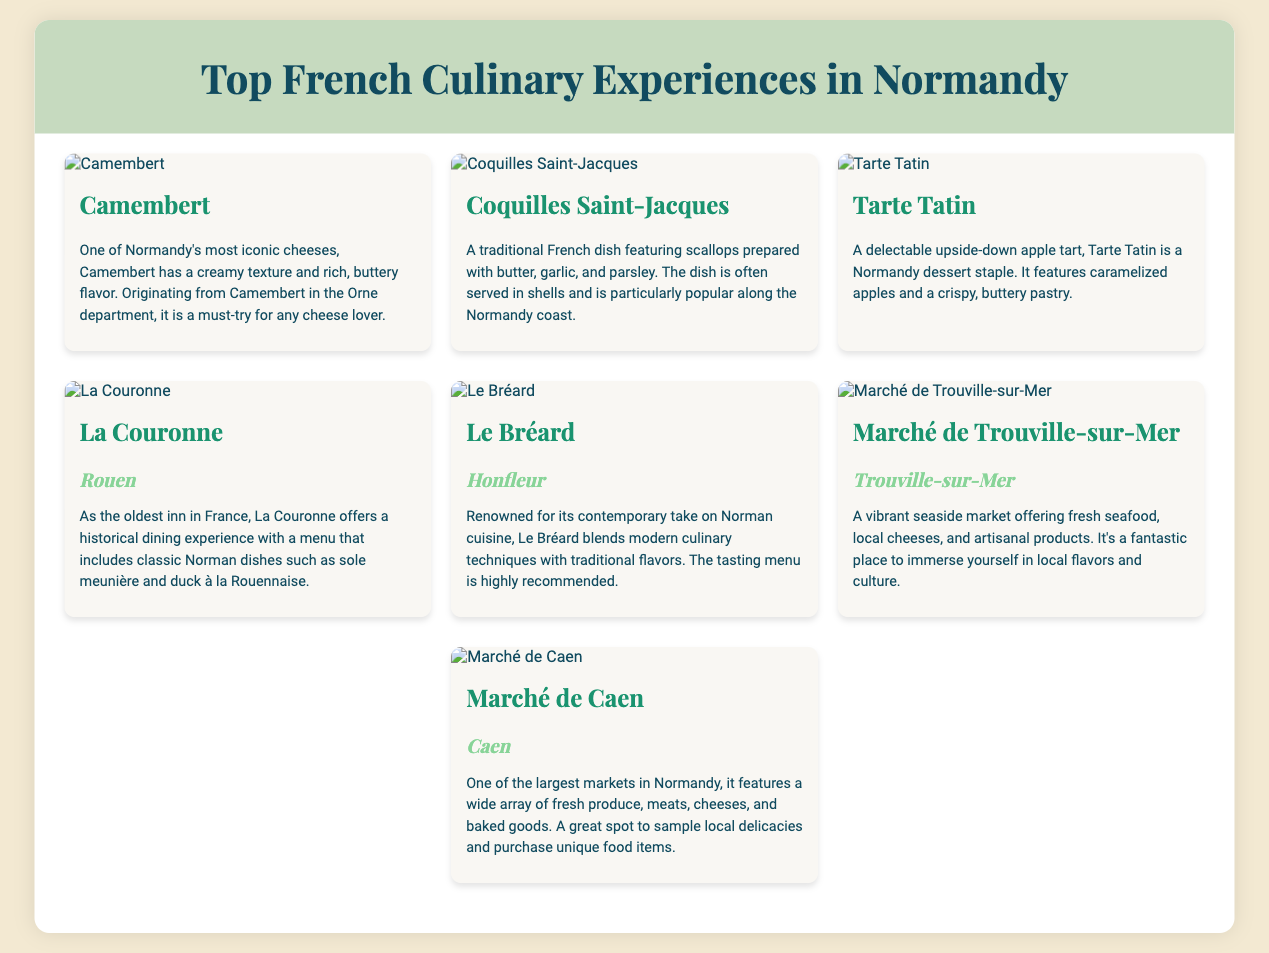What is one of Normandy's most iconic cheeses? The document mentions Camembert as one of Normandy's most iconic cheeses.
Answer: Camembert What dish features scallops prepared with butter, garlic, and parsley? The dish described with scallops prepared with butter, garlic, and parsley is Coquilles Saint-Jacques.
Answer: Coquilles Saint-Jacques What is the main dessert staple of Normandy? The main dessert staple of Normandy mentioned in the document is Tarte Tatin.
Answer: Tarte Tatin Which restaurant is known as the oldest inn in France? The document states that La Couronne is the oldest inn in France.
Answer: La Couronne Where is Le Bréard located? The location of Le Bréard mentioned in the document is Honfleur.
Answer: Honfleur What type of products can be found at Marché de Trouville-sur-Mer? Marché de Trouville-sur-Mer features fresh seafood, local cheeses, and artisanal products.
Answer: Fresh seafood, local cheeses, and artisanal products Which market is one of the largest in Normandy? The document states that Marché de Caen is one of the largest markets in Normandy.
Answer: Marché de Caen What is a recommended option to experience local flavors in Trouville-sur-Mer? The document suggests that visiting Marché de Trouville-sur-Mer is a great way to experience local flavors.
Answer: Marché de Trouville-sur-Mer 